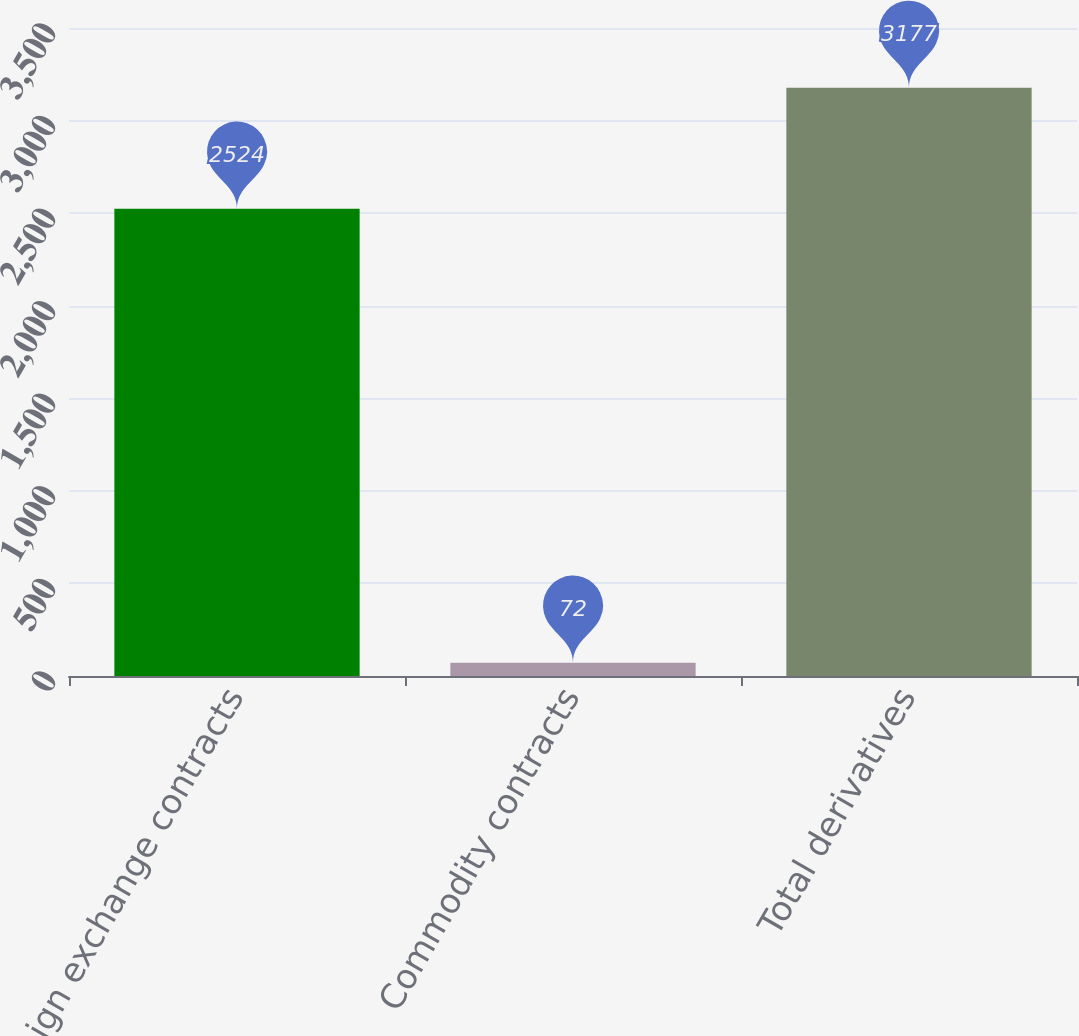Convert chart to OTSL. <chart><loc_0><loc_0><loc_500><loc_500><bar_chart><fcel>Foreign exchange contracts<fcel>Commodity contracts<fcel>Total derivatives<nl><fcel>2524<fcel>72<fcel>3177<nl></chart> 